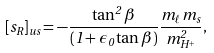<formula> <loc_0><loc_0><loc_500><loc_500>[ s _ { R } ] _ { u s } = - \frac { \tan ^ { 2 } \beta } { ( 1 + \epsilon _ { 0 } \tan \beta ) } \frac { m _ { \ell } m _ { s } } { m _ { H ^ { + } } ^ { 2 } } ,</formula> 